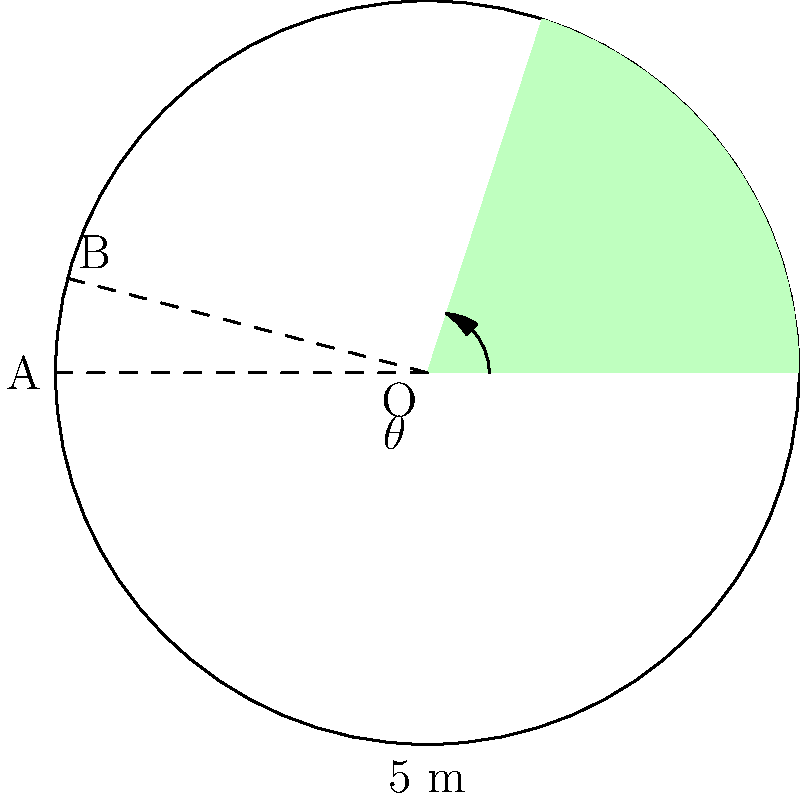In your circular herb garden, you've decided to create a pie-shaped section for a new variety of mint. The garden has a diameter of 10 meters, and the arc length of the mint section is 6.28 meters. What is the central angle $\theta$ (in degrees) of this pie-shaped section? Let's approach this step-by-step:

1) First, we need to recall the formula for arc length:
   Arc length = $\frac{\theta}{360^\circ} \cdot 2\pi r$, where $\theta$ is in degrees and $r$ is the radius.

2) We're given the diameter of 10 meters, so the radius $r$ is 5 meters.

3) We're also given the arc length of 6.28 meters.

4) Let's substitute these into our formula:
   $6.28 = \frac{\theta}{360^\circ} \cdot 2\pi \cdot 5$

5) Simplify the right side:
   $6.28 = \frac{\theta}{360^\circ} \cdot 10\pi$

6) Now, let's solve for $\theta$:
   $\frac{6.28}{10\pi} = \frac{\theta}{360^\circ}$

7) Multiply both sides by $360^\circ$:
   $\frac{6.28}{10\pi} \cdot 360^\circ = \theta$

8) Simplify:
   $\frac{6.28 \cdot 360}{10\pi} = \theta$

9) Calculate:
   $\theta \approx 72^\circ$

Therefore, the central angle of the pie-shaped mint section is approximately 72°.
Answer: $72^\circ$ 